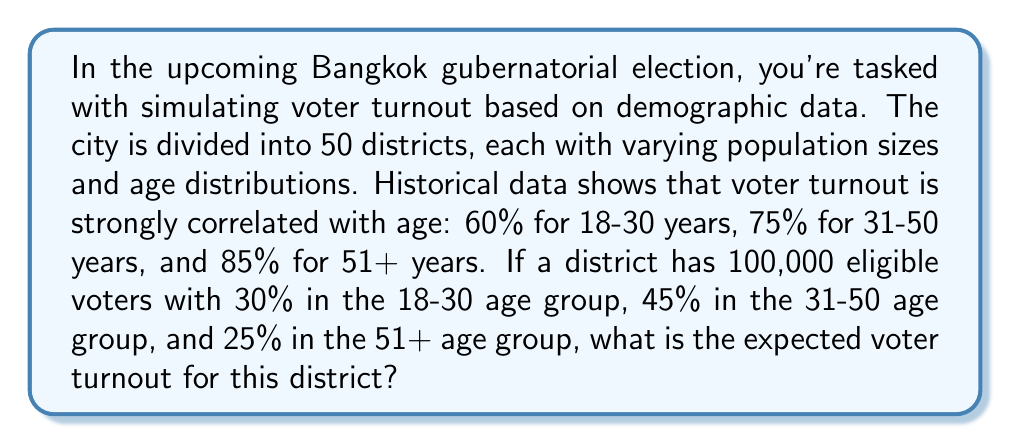Can you solve this math problem? To solve this problem, we'll follow these steps:

1. Calculate the number of eligible voters in each age group:
   18-30 years: $100,000 \times 0.30 = 30,000$
   31-50 years: $100,000 \times 0.45 = 45,000$
   51+ years:   $100,000 \times 0.25 = 25,000$

2. Calculate the expected turnout for each age group:
   18-30 years: $30,000 \times 0.60 = 18,000$
   31-50 years: $45,000 \times 0.75 = 33,750$
   51+ years:   $25,000 \times 0.85 = 21,250$

3. Sum up the expected turnout from all age groups:
   $18,000 + 33,750 + 21,250 = 73,000$

4. Calculate the overall turnout percentage:
   $$\text{Turnout Percentage} = \frac{\text{Expected Turnout}}{\text{Total Eligible Voters}} \times 100\%$$
   $$\text{Turnout Percentage} = \frac{73,000}{100,000} \times 100\% = 73\%$$

Therefore, the expected voter turnout for this district is 73,000 voters or 73% of eligible voters.
Answer: 73,000 voters (73%) 